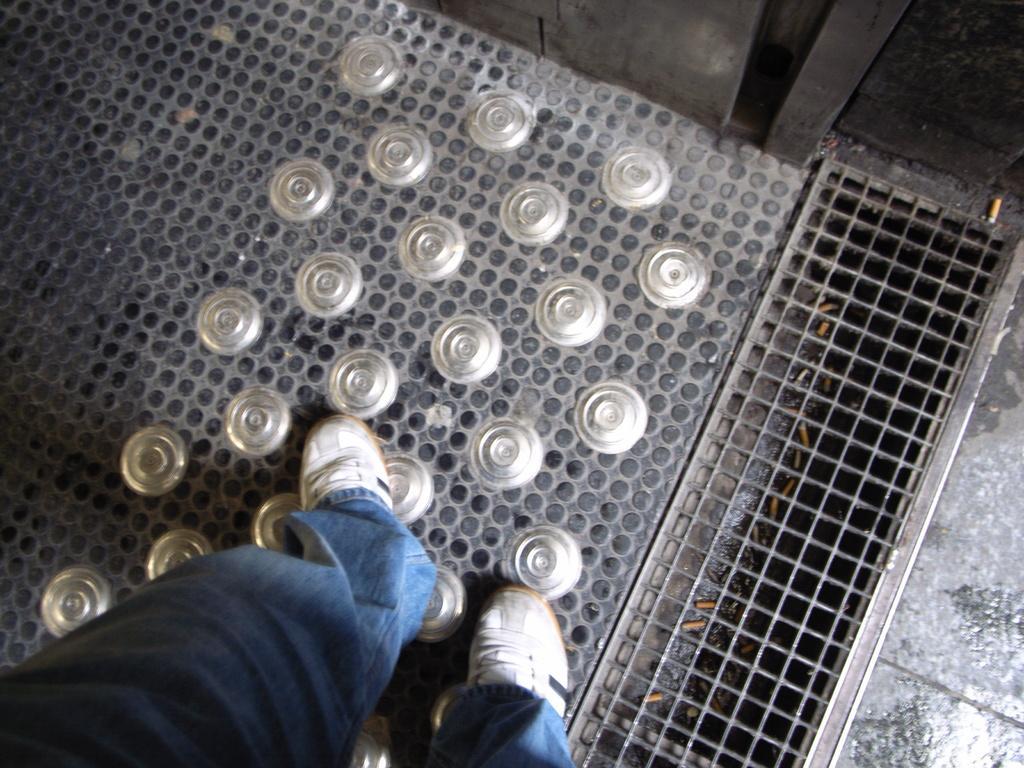In one or two sentences, can you explain what this image depicts? In this picture I can see a person standing on the iron floor, and there is a mesh. 